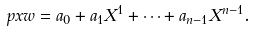<formula> <loc_0><loc_0><loc_500><loc_500>\ p x { w } = a _ { 0 } + a _ { 1 } X ^ { 1 } + \dots + a _ { n - 1 } X ^ { n - 1 } .</formula> 